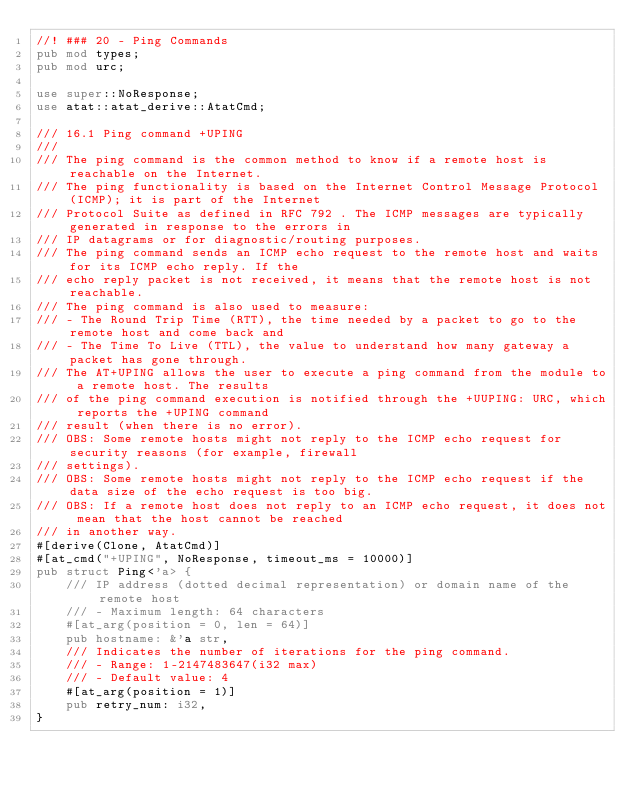Convert code to text. <code><loc_0><loc_0><loc_500><loc_500><_Rust_>//! ### 20 - Ping Commands
pub mod types;
pub mod urc;

use super::NoResponse;
use atat::atat_derive::AtatCmd;

/// 16.1 Ping command +UPING
///
/// The ping command is the common method to know if a remote host is reachable on the Internet.
/// The ping functionality is based on the Internet Control Message Protocol (ICMP); it is part of the Internet
/// Protocol Suite as defined in RFC 792 . The ICMP messages are typically generated in response to the errors in
/// IP datagrams or for diagnostic/routing purposes.
/// The ping command sends an ICMP echo request to the remote host and waits for its ICMP echo reply. If the
/// echo reply packet is not received, it means that the remote host is not reachable.
/// The ping command is also used to measure:
/// - The Round Trip Time (RTT), the time needed by a packet to go to the remote host and come back and
/// - The Time To Live (TTL), the value to understand how many gateway a packet has gone through.
/// The AT+UPING allows the user to execute a ping command from the module to a remote host. The results
/// of the ping command execution is notified through the +UUPING: URC, which reports the +UPING command
/// result (when there is no error).
/// OBS: Some remote hosts might not reply to the ICMP echo request for security reasons (for example, firewall
/// settings).
/// OBS: Some remote hosts might not reply to the ICMP echo request if the data size of the echo request is too big.
/// OBS: If a remote host does not reply to an ICMP echo request, it does not mean that the host cannot be reached
/// in another way.
#[derive(Clone, AtatCmd)]
#[at_cmd("+UPING", NoResponse, timeout_ms = 10000)]
pub struct Ping<'a> {
    /// IP address (dotted decimal representation) or domain name of the remote host
    /// - Maximum length: 64 characters
    #[at_arg(position = 0, len = 64)]
    pub hostname: &'a str,
    /// Indicates the number of iterations for the ping command.
    /// - Range: 1-2147483647(i32 max)
    /// - Default value: 4
    #[at_arg(position = 1)]
    pub retry_num: i32,
}
</code> 